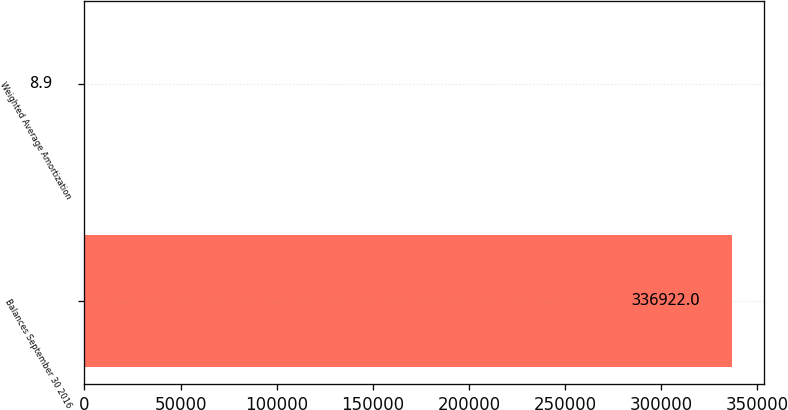<chart> <loc_0><loc_0><loc_500><loc_500><bar_chart><fcel>Balances September 30 2016<fcel>Weighted Average Amortization<nl><fcel>336922<fcel>8.9<nl></chart> 